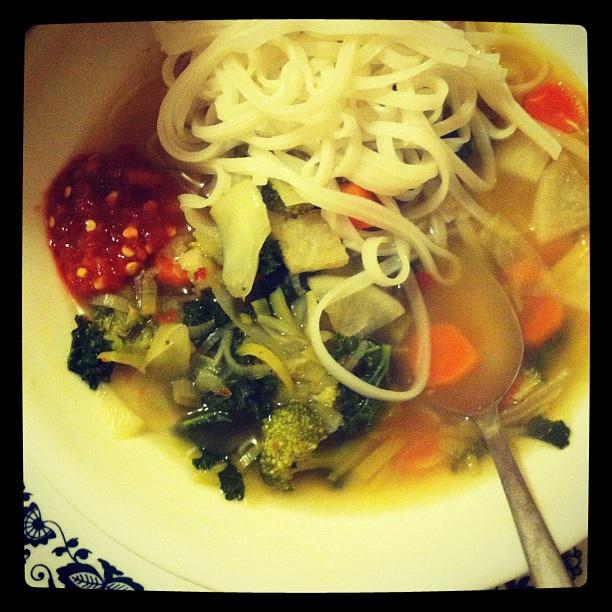Is this healthy?
Give a very brief answer. Yes. Are they having soup?
Be succinct. Yes. Is the soup filled to the top of the bowl?
Give a very brief answer. No. What utensil are they eating with?
Write a very short answer. Spoon. What is the brown stuff on the bottom right?
Be succinct. Broth. What is on top of the beans?
Short answer required. Noodles. Is there a slice of cucumber on the plate?
Give a very brief answer. No. What meal of the day is this being eaten at?
Give a very brief answer. Lunch. 